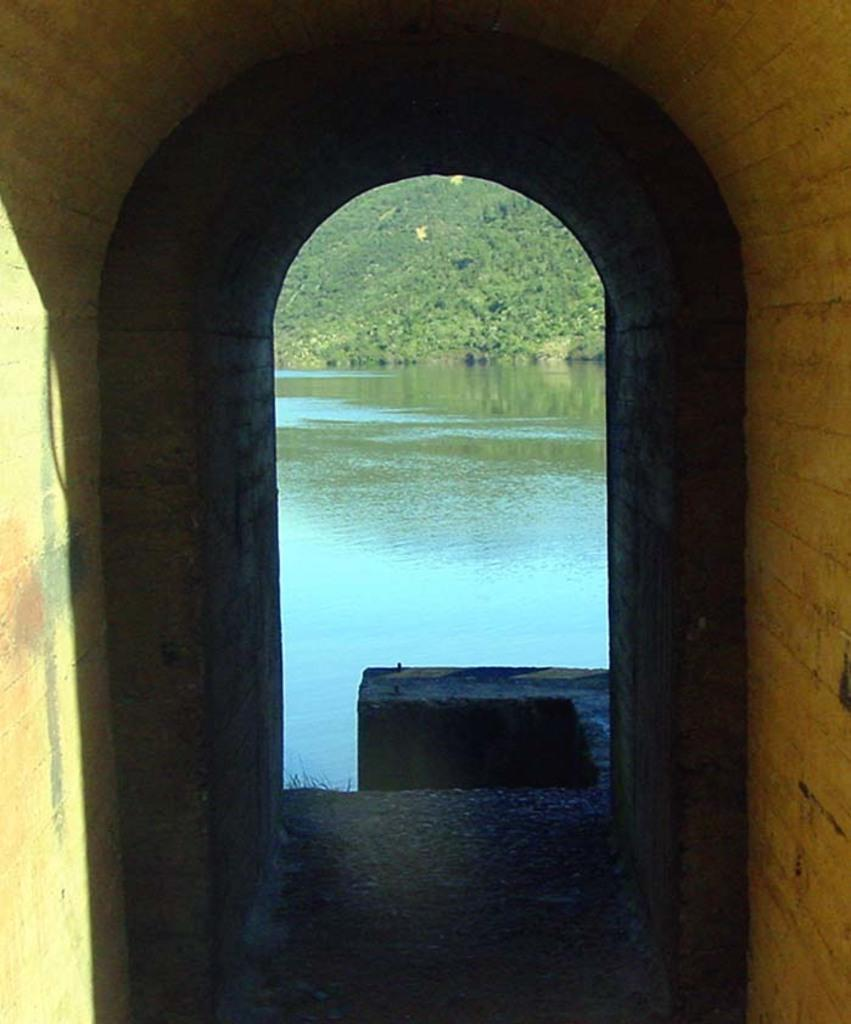What type of structure can be seen in the image? There is a tunnel in the image. What else can be seen in the image besides the tunnel? There is a path visible in the image. What can be seen in the background of the image? Water and greenery are visible in the background of the image. What color is the paint on the skate in the image? There is no skate or paint present in the image. How many bees can be seen buzzing around the tunnel in the image? There are no bees visible in the image. 